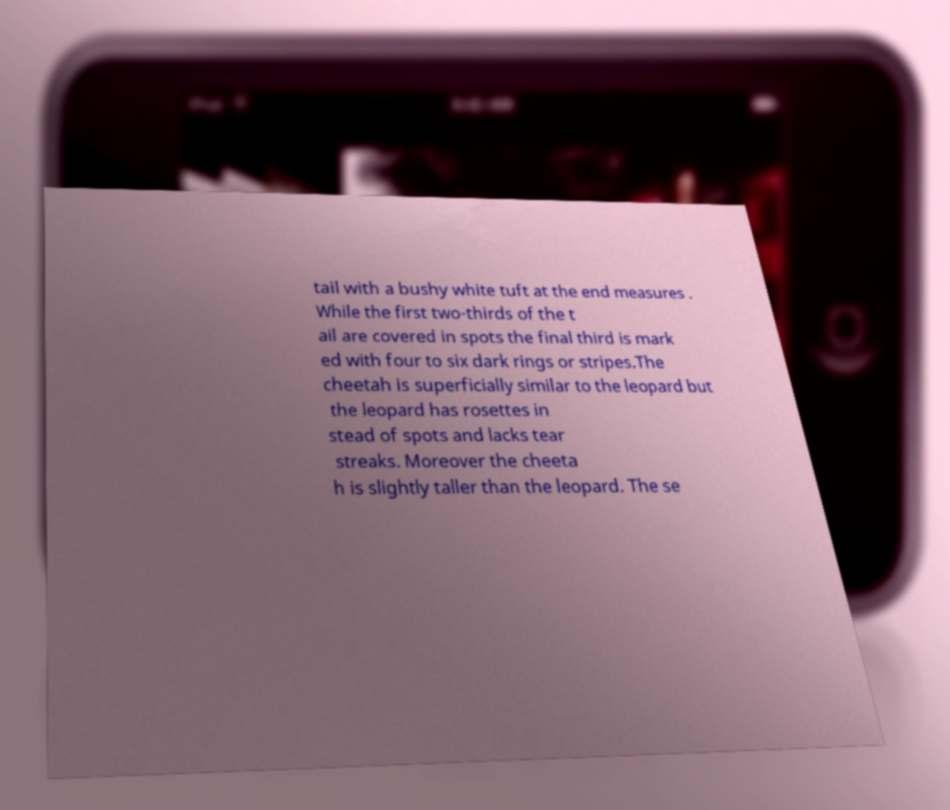Could you extract and type out the text from this image? tail with a bushy white tuft at the end measures . While the first two-thirds of the t ail are covered in spots the final third is mark ed with four to six dark rings or stripes.The cheetah is superficially similar to the leopard but the leopard has rosettes in stead of spots and lacks tear streaks. Moreover the cheeta h is slightly taller than the leopard. The se 